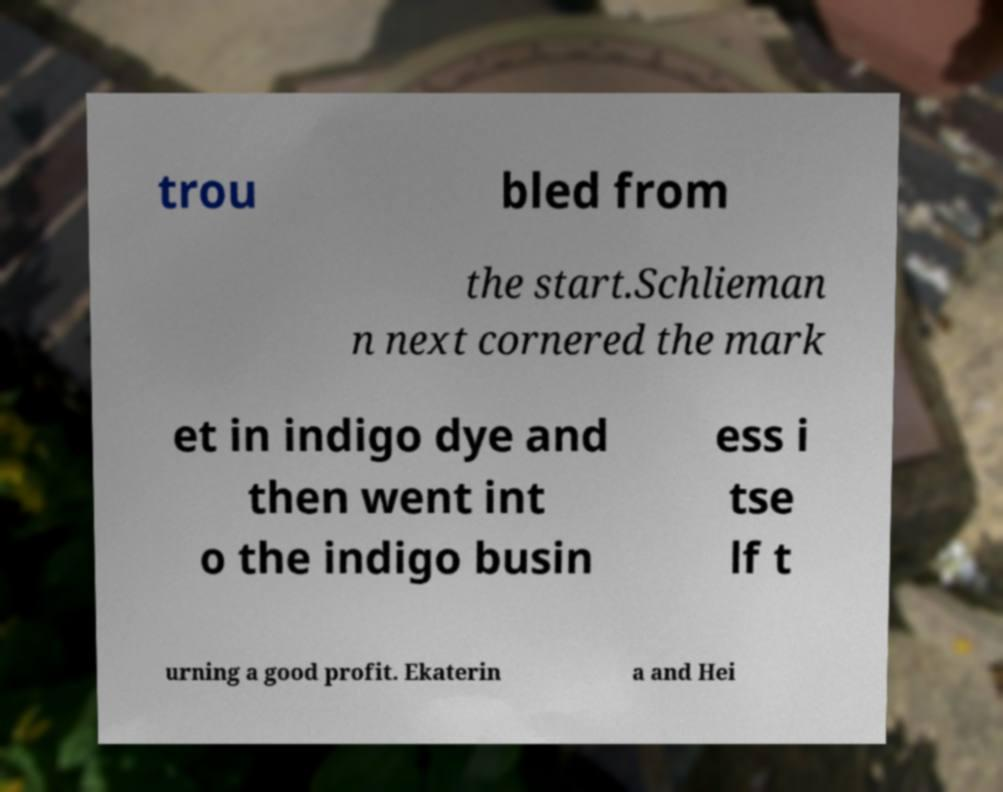Please read and relay the text visible in this image. What does it say? trou bled from the start.Schlieman n next cornered the mark et in indigo dye and then went int o the indigo busin ess i tse lf t urning a good profit. Ekaterin a and Hei 